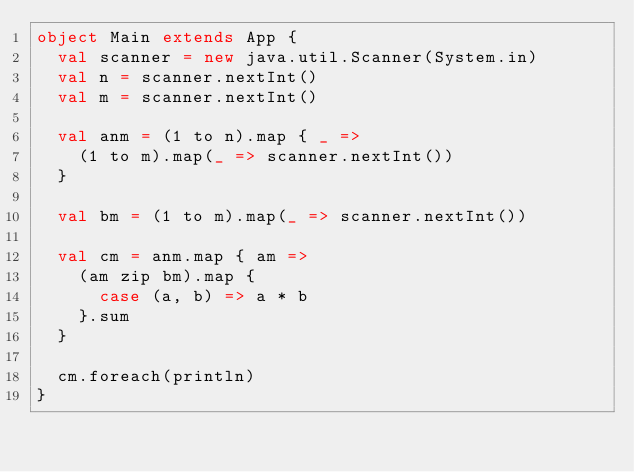<code> <loc_0><loc_0><loc_500><loc_500><_Scala_>object Main extends App {
  val scanner = new java.util.Scanner(System.in)
  val n = scanner.nextInt()
  val m = scanner.nextInt()

  val anm = (1 to n).map { _ =>
    (1 to m).map(_ => scanner.nextInt())
  }

  val bm = (1 to m).map(_ => scanner.nextInt())

  val cm = anm.map { am =>
    (am zip bm).map {
      case (a, b) => a * b
    }.sum
  }

  cm.foreach(println)
}</code> 